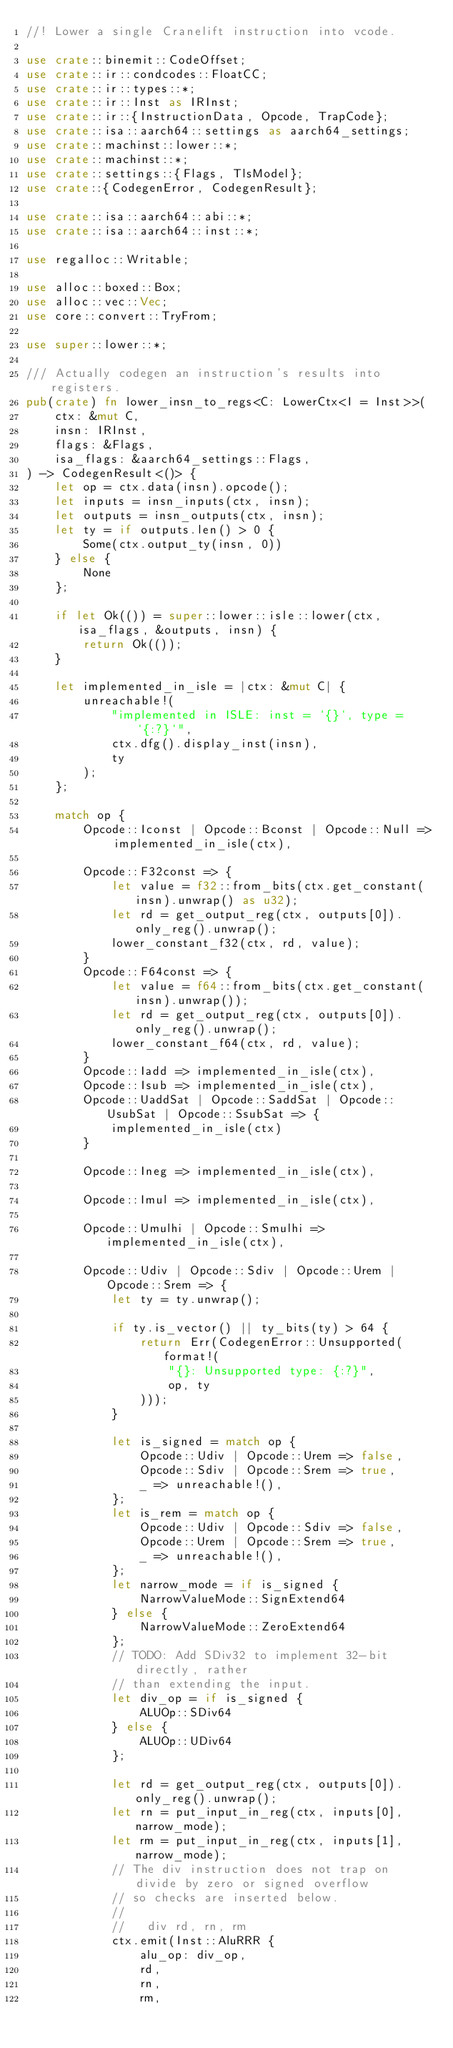Convert code to text. <code><loc_0><loc_0><loc_500><loc_500><_Rust_>//! Lower a single Cranelift instruction into vcode.

use crate::binemit::CodeOffset;
use crate::ir::condcodes::FloatCC;
use crate::ir::types::*;
use crate::ir::Inst as IRInst;
use crate::ir::{InstructionData, Opcode, TrapCode};
use crate::isa::aarch64::settings as aarch64_settings;
use crate::machinst::lower::*;
use crate::machinst::*;
use crate::settings::{Flags, TlsModel};
use crate::{CodegenError, CodegenResult};

use crate::isa::aarch64::abi::*;
use crate::isa::aarch64::inst::*;

use regalloc::Writable;

use alloc::boxed::Box;
use alloc::vec::Vec;
use core::convert::TryFrom;

use super::lower::*;

/// Actually codegen an instruction's results into registers.
pub(crate) fn lower_insn_to_regs<C: LowerCtx<I = Inst>>(
    ctx: &mut C,
    insn: IRInst,
    flags: &Flags,
    isa_flags: &aarch64_settings::Flags,
) -> CodegenResult<()> {
    let op = ctx.data(insn).opcode();
    let inputs = insn_inputs(ctx, insn);
    let outputs = insn_outputs(ctx, insn);
    let ty = if outputs.len() > 0 {
        Some(ctx.output_ty(insn, 0))
    } else {
        None
    };

    if let Ok(()) = super::lower::isle::lower(ctx, isa_flags, &outputs, insn) {
        return Ok(());
    }

    let implemented_in_isle = |ctx: &mut C| {
        unreachable!(
            "implemented in ISLE: inst = `{}`, type = `{:?}`",
            ctx.dfg().display_inst(insn),
            ty
        );
    };

    match op {
        Opcode::Iconst | Opcode::Bconst | Opcode::Null => implemented_in_isle(ctx),

        Opcode::F32const => {
            let value = f32::from_bits(ctx.get_constant(insn).unwrap() as u32);
            let rd = get_output_reg(ctx, outputs[0]).only_reg().unwrap();
            lower_constant_f32(ctx, rd, value);
        }
        Opcode::F64const => {
            let value = f64::from_bits(ctx.get_constant(insn).unwrap());
            let rd = get_output_reg(ctx, outputs[0]).only_reg().unwrap();
            lower_constant_f64(ctx, rd, value);
        }
        Opcode::Iadd => implemented_in_isle(ctx),
        Opcode::Isub => implemented_in_isle(ctx),
        Opcode::UaddSat | Opcode::SaddSat | Opcode::UsubSat | Opcode::SsubSat => {
            implemented_in_isle(ctx)
        }

        Opcode::Ineg => implemented_in_isle(ctx),

        Opcode::Imul => implemented_in_isle(ctx),

        Opcode::Umulhi | Opcode::Smulhi => implemented_in_isle(ctx),

        Opcode::Udiv | Opcode::Sdiv | Opcode::Urem | Opcode::Srem => {
            let ty = ty.unwrap();

            if ty.is_vector() || ty_bits(ty) > 64 {
                return Err(CodegenError::Unsupported(format!(
                    "{}: Unsupported type: {:?}",
                    op, ty
                )));
            }

            let is_signed = match op {
                Opcode::Udiv | Opcode::Urem => false,
                Opcode::Sdiv | Opcode::Srem => true,
                _ => unreachable!(),
            };
            let is_rem = match op {
                Opcode::Udiv | Opcode::Sdiv => false,
                Opcode::Urem | Opcode::Srem => true,
                _ => unreachable!(),
            };
            let narrow_mode = if is_signed {
                NarrowValueMode::SignExtend64
            } else {
                NarrowValueMode::ZeroExtend64
            };
            // TODO: Add SDiv32 to implement 32-bit directly, rather
            // than extending the input.
            let div_op = if is_signed {
                ALUOp::SDiv64
            } else {
                ALUOp::UDiv64
            };

            let rd = get_output_reg(ctx, outputs[0]).only_reg().unwrap();
            let rn = put_input_in_reg(ctx, inputs[0], narrow_mode);
            let rm = put_input_in_reg(ctx, inputs[1], narrow_mode);
            // The div instruction does not trap on divide by zero or signed overflow
            // so checks are inserted below.
            //
            //   div rd, rn, rm
            ctx.emit(Inst::AluRRR {
                alu_op: div_op,
                rd,
                rn,
                rm,</code> 